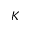<formula> <loc_0><loc_0><loc_500><loc_500>K</formula> 